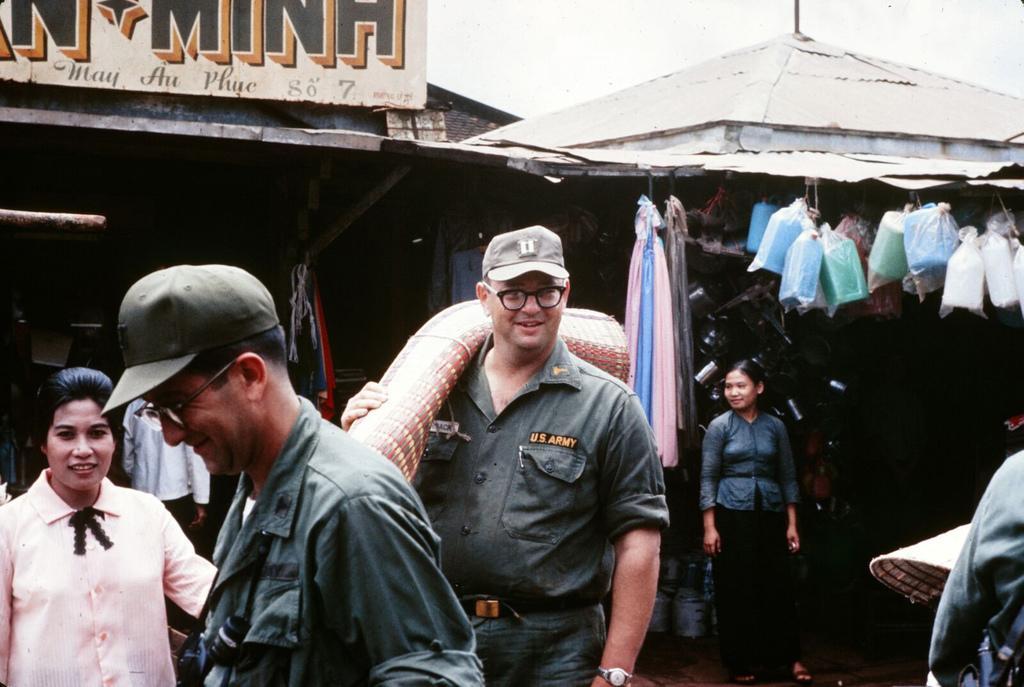Could you give a brief overview of what you see in this image? In the background we can see the stores and a board. In this picture we can see the objects and few objects are hanging with the help of ropes. We can see the people. We can see a man carrying an object on his shoulder and holding it with his hand. He is smiling. 